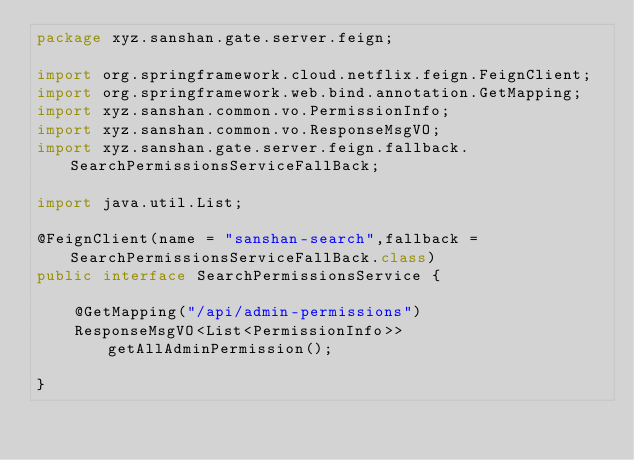<code> <loc_0><loc_0><loc_500><loc_500><_Java_>package xyz.sanshan.gate.server.feign;

import org.springframework.cloud.netflix.feign.FeignClient;
import org.springframework.web.bind.annotation.GetMapping;
import xyz.sanshan.common.vo.PermissionInfo;
import xyz.sanshan.common.vo.ResponseMsgVO;
import xyz.sanshan.gate.server.feign.fallback.SearchPermissionsServiceFallBack;

import java.util.List;

@FeignClient(name = "sanshan-search",fallback = SearchPermissionsServiceFallBack.class)
public interface SearchPermissionsService {

    @GetMapping("/api/admin-permissions")
    ResponseMsgVO<List<PermissionInfo>> getAllAdminPermission();

}
</code> 